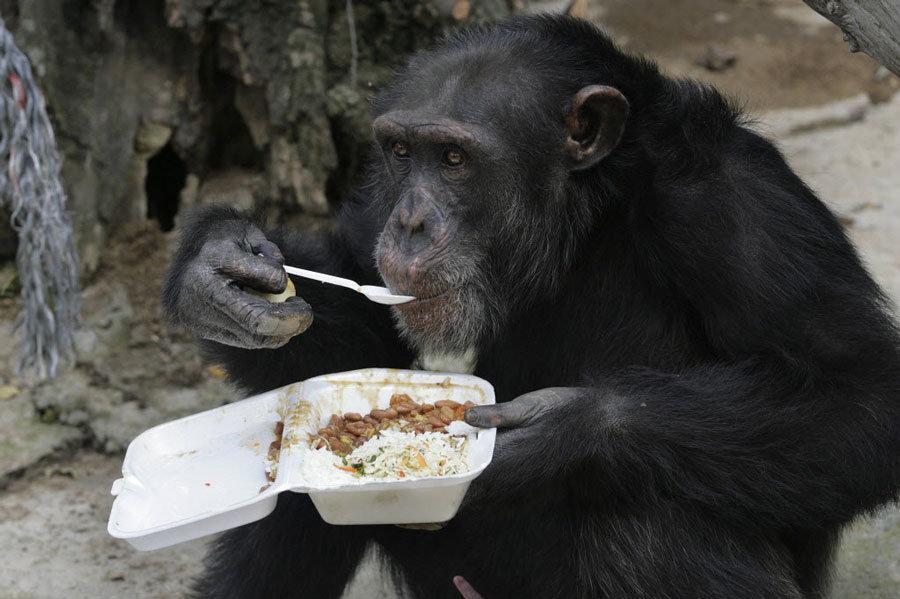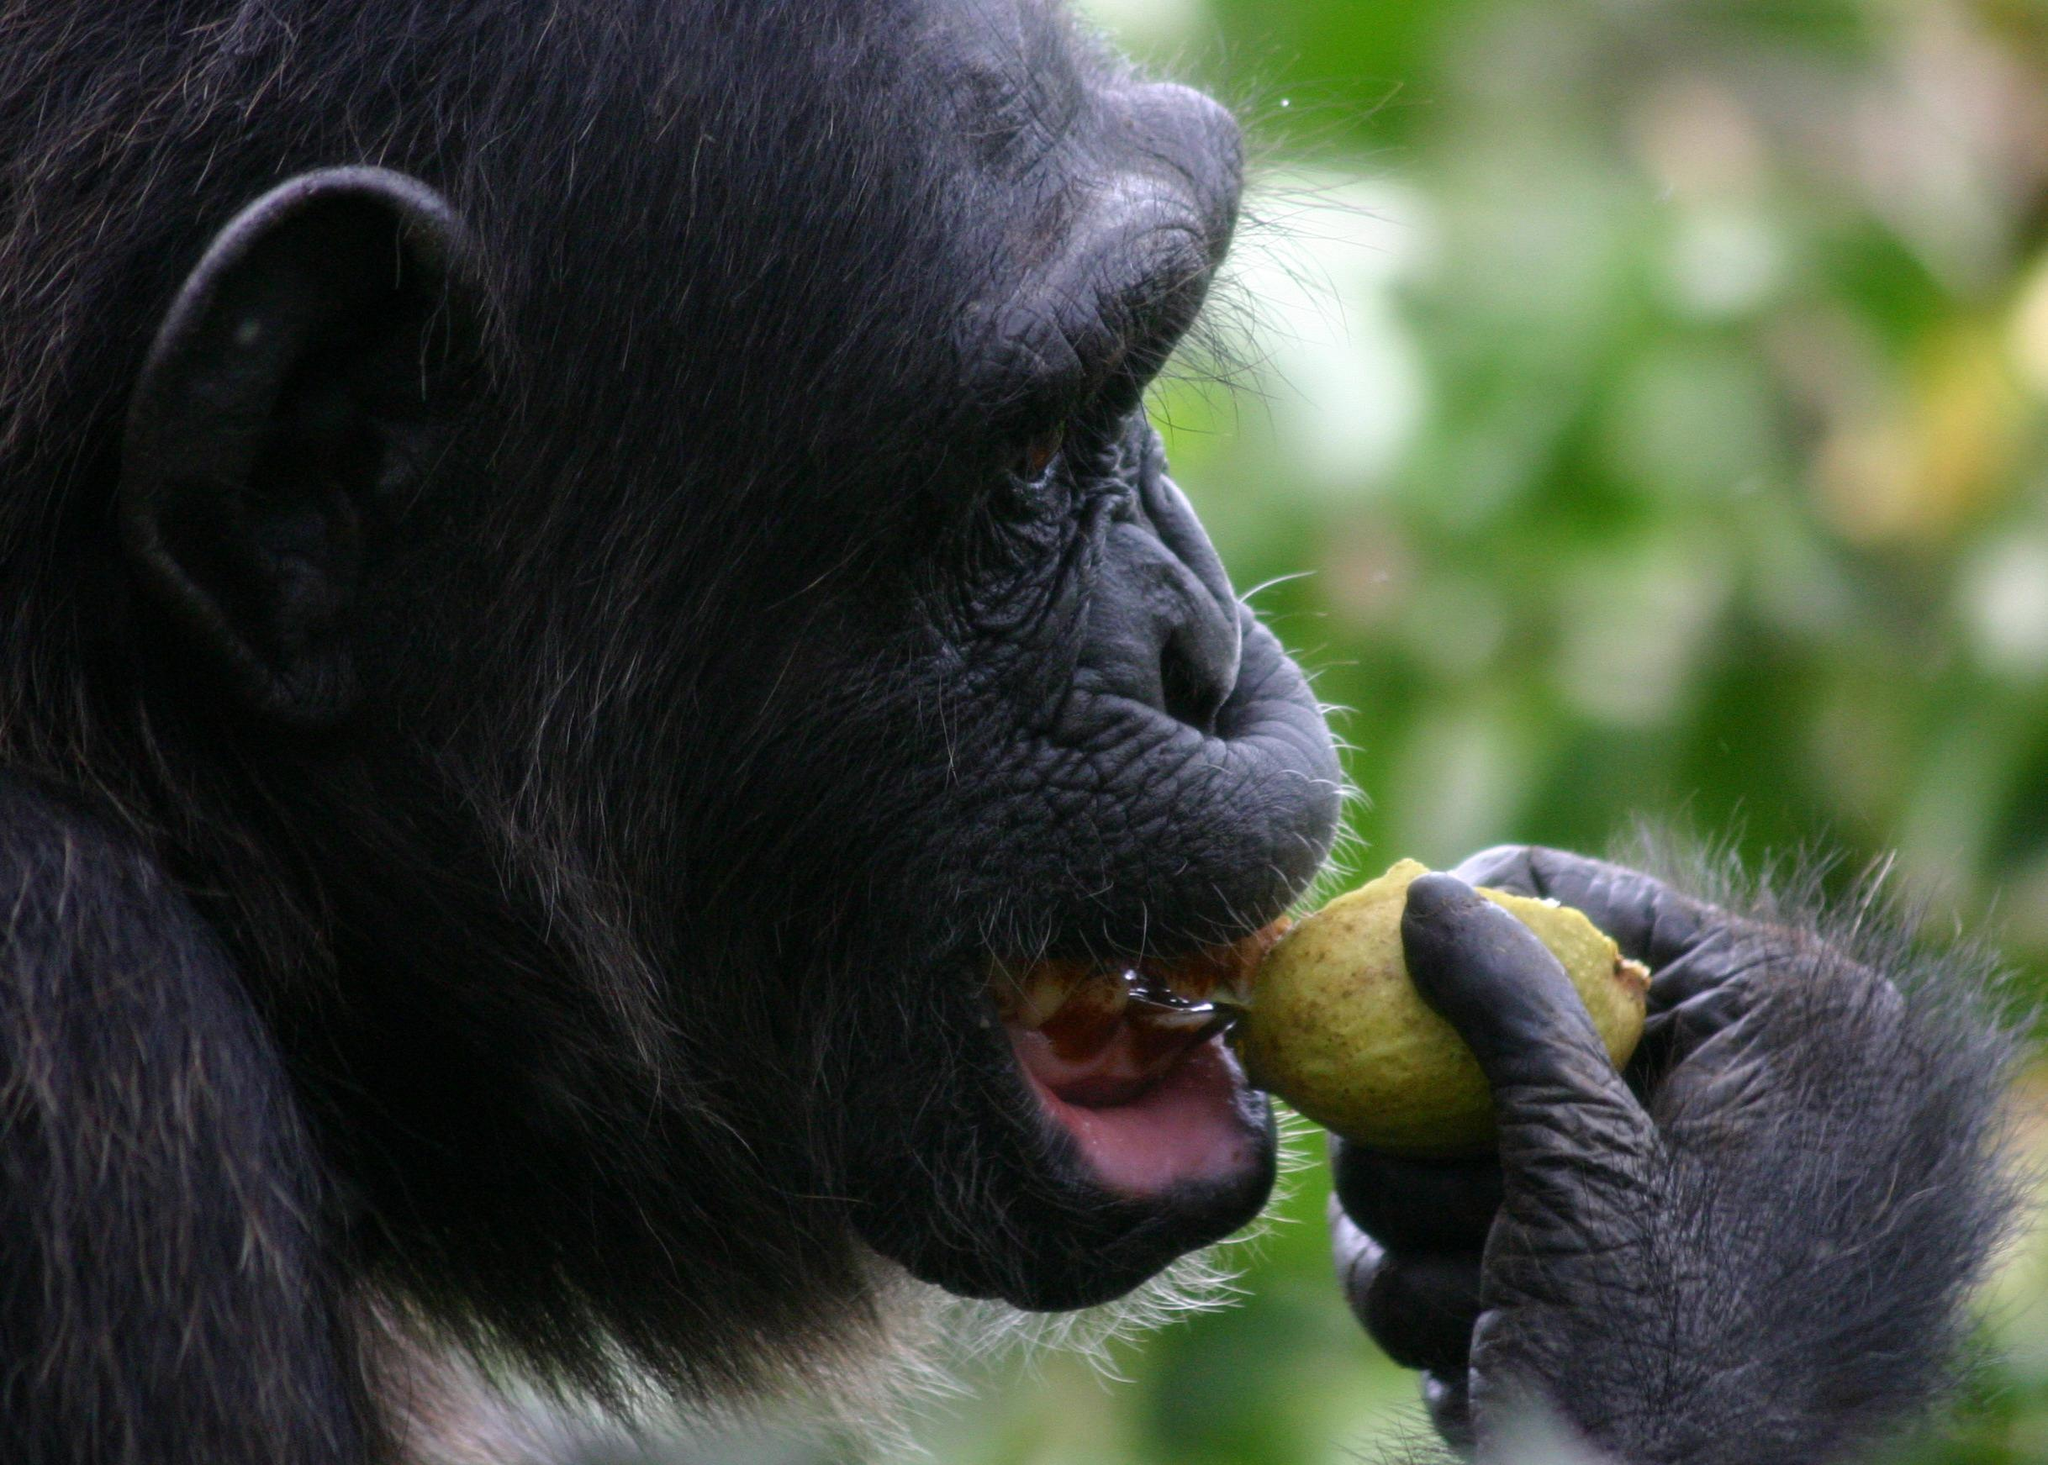The first image is the image on the left, the second image is the image on the right. Evaluate the accuracy of this statement regarding the images: "One of the monkeys is not eating.". Is it true? Answer yes or no. No. The first image is the image on the left, the second image is the image on the right. Evaluate the accuracy of this statement regarding the images: "At least one chimp has something to eat in each image, and no chimp is using cutlery to eat.". Is it true? Answer yes or no. No. 